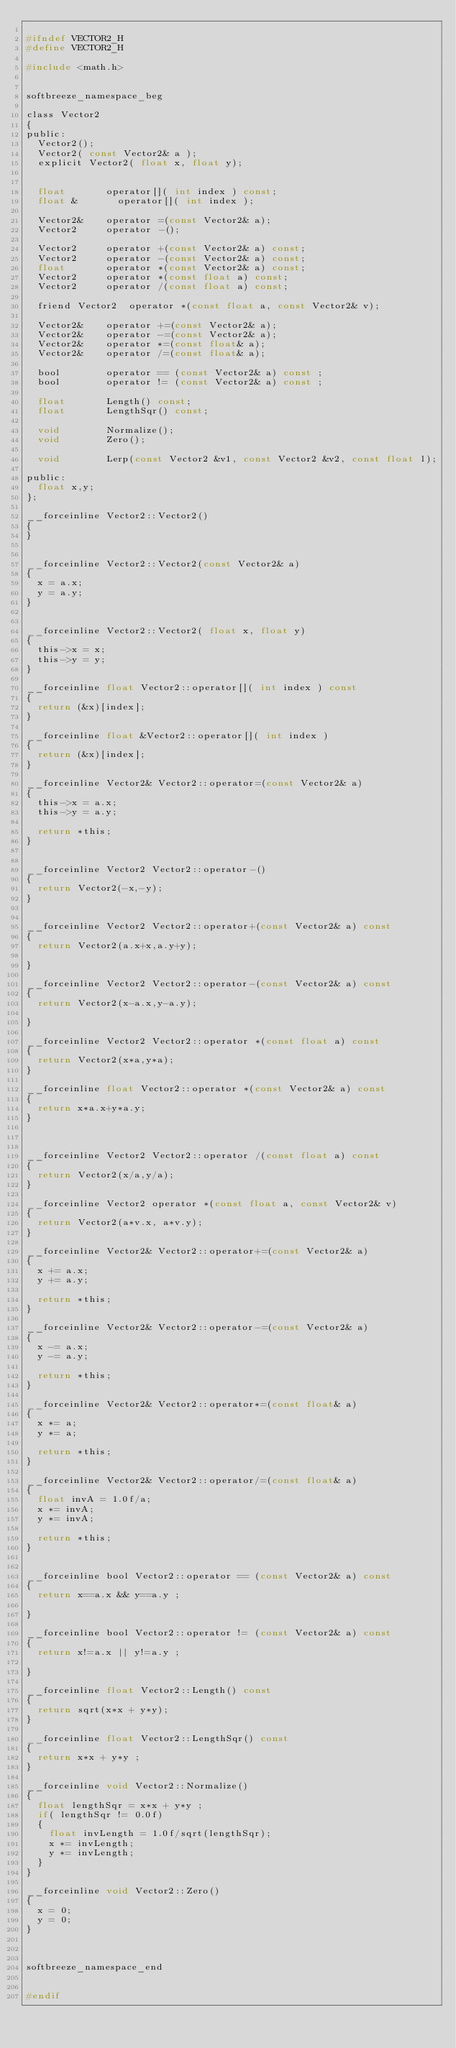<code> <loc_0><loc_0><loc_500><loc_500><_C_>
#ifndef VECTOR2_H
#define VECTOR2_H

#include <math.h>


softbreeze_namespace_beg

class Vector2
{
public:
	Vector2();
	Vector2( const Vector2& a );
	explicit Vector2( float x, float y);


	float				operator[]( int index ) const;
	float &				operator[]( int index );

	Vector2&		operator =(const Vector2& a);
	Vector2			operator -();

	Vector2			operator +(const Vector2& a) const; 
	Vector2			operator -(const Vector2& a) const;  
	float				operator *(const Vector2& a) const;
	Vector2			operator *(const float a) const;
	Vector2			operator /(const float a) const;

	friend Vector2	operator *(const float a, const Vector2& v);

	Vector2&		operator +=(const Vector2& a);
	Vector2&		operator -=(const Vector2& a);
	Vector2&		operator *=(const float& a);
	Vector2&		operator /=(const float& a);

	bool				operator == (const Vector2& a) const ;
	bool				operator != (const Vector2& a) const ;

	float				Length() const;
	float				LengthSqr() const;

	void				Normalize();
	void				Zero();

	void				Lerp(const Vector2 &v1, const Vector2 &v2, const float l);

public:
	float x,y;
};

__forceinline Vector2::Vector2()
{
}


__forceinline Vector2::Vector2(const Vector2& a)
{
	x = a.x;
	y = a.y;
}


__forceinline Vector2::Vector2( float x, float y)
{
	this->x = x;
	this->y = y;
}

__forceinline float Vector2::operator[]( int index ) const
{
	return (&x)[index];
}

__forceinline float &Vector2::operator[]( int index )
{
	return (&x)[index];
}

__forceinline Vector2& Vector2::operator=(const Vector2& a)
{
	this->x = a.x;
	this->y = a.y;

	return *this;
}


__forceinline Vector2 Vector2::operator-() 
{
	return Vector2(-x,-y);
}


__forceinline Vector2 Vector2::operator+(const Vector2& a) const
{
	return Vector2(a.x+x,a.y+y);

}

__forceinline Vector2 Vector2::operator-(const Vector2& a) const
{
	return Vector2(x-a.x,y-a.y);

}

__forceinline Vector2 Vector2::operator *(const float a) const
{
	return Vector2(x*a,y*a);
}

__forceinline float Vector2::operator *(const Vector2& a) const
{
	return x*a.x+y*a.y;
}



__forceinline Vector2 Vector2::operator /(const float a) const
{
	return Vector2(x/a,y/a);
}

__forceinline Vector2	operator *(const float a, const Vector2& v)
{
	return Vector2(a*v.x, a*v.y);
}

__forceinline Vector2& Vector2::operator+=(const Vector2& a) 
{
	x += a.x;
	y += a.y;

	return *this;
}

__forceinline Vector2& Vector2::operator-=(const Vector2& a) 
{
	x -= a.x;
	y -= a.y;

	return *this;
}

__forceinline Vector2& Vector2::operator*=(const float& a) 
{
	x *= a;
	y *= a;

	return *this;
}

__forceinline Vector2& Vector2::operator/=(const float& a) 
{
	float invA = 1.0f/a;
	x *= invA;
	y *= invA;

	return *this;
}


__forceinline bool Vector2::operator == (const Vector2& a) const
{
	return x==a.x && y==a.y ;

}

__forceinline bool Vector2::operator != (const Vector2& a) const
{
	return x!=a.x || y!=a.y ;

}

__forceinline float Vector2::Length() const
{
	return sqrt(x*x + y*y);
}

__forceinline float Vector2::LengthSqr() const
{
	return x*x + y*y ;
}

__forceinline void Vector2::Normalize()
{
	float lengthSqr = x*x + y*y ;
	if( lengthSqr != 0.0f)
	{
		float invLength = 1.0f/sqrt(lengthSqr);
		x *= invLength;
		y *= invLength;
	}
}

__forceinline void Vector2::Zero()
{
	x = 0;
	y = 0;
}



softbreeze_namespace_end


#endif

</code> 